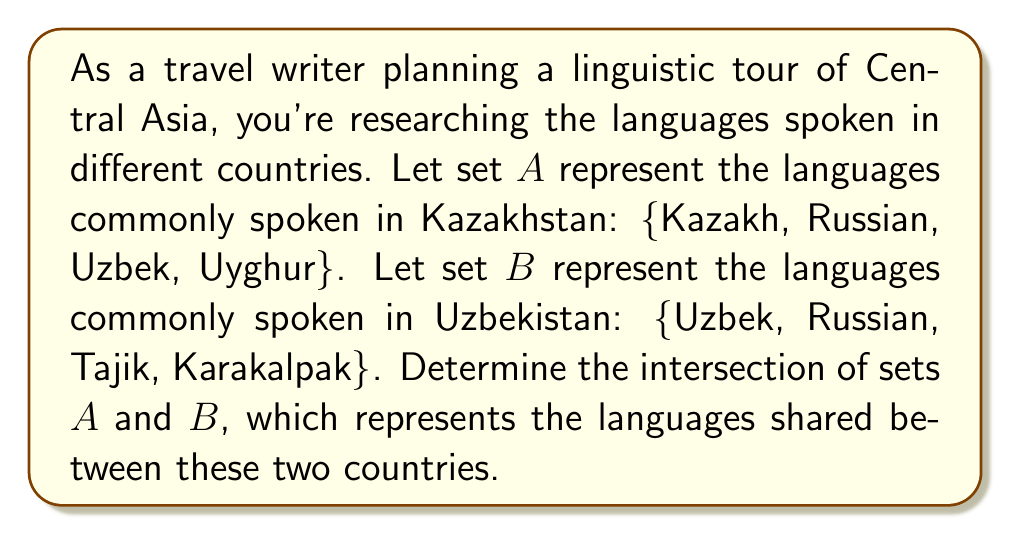What is the answer to this math problem? To solve this problem, we need to identify the elements that are common to both sets. Let's approach this step-by-step:

1. First, let's write out our sets:
   Set A (Kazakhstan) = {Kazakh, Russian, Uzbek, Uyghur}
   Set B (Uzbekistan) = {Uzbek, Russian, Tajik, Karakalpak}

2. The intersection of two sets is denoted by $A \cap B$ and contains all elements that are in both A and B.

3. Let's compare each element of set A with the elements of set B:
   - Kazakh: Not in set B
   - Russian: Also in set B
   - Uzbek: Also in set B
   - Uyghur: Not in set B

4. Therefore, the languages that appear in both sets are Russian and Uzbek.

5. We can write this intersection as:
   $A \cap B = \text{\{Russian, Uzbek\}}$

This result shows that Russian and Uzbek are the languages shared between Kazakhstan and Uzbekistan, according to our given sets.
Answer: $A \cap B = \text{\{Russian, Uzbek\}}$ 